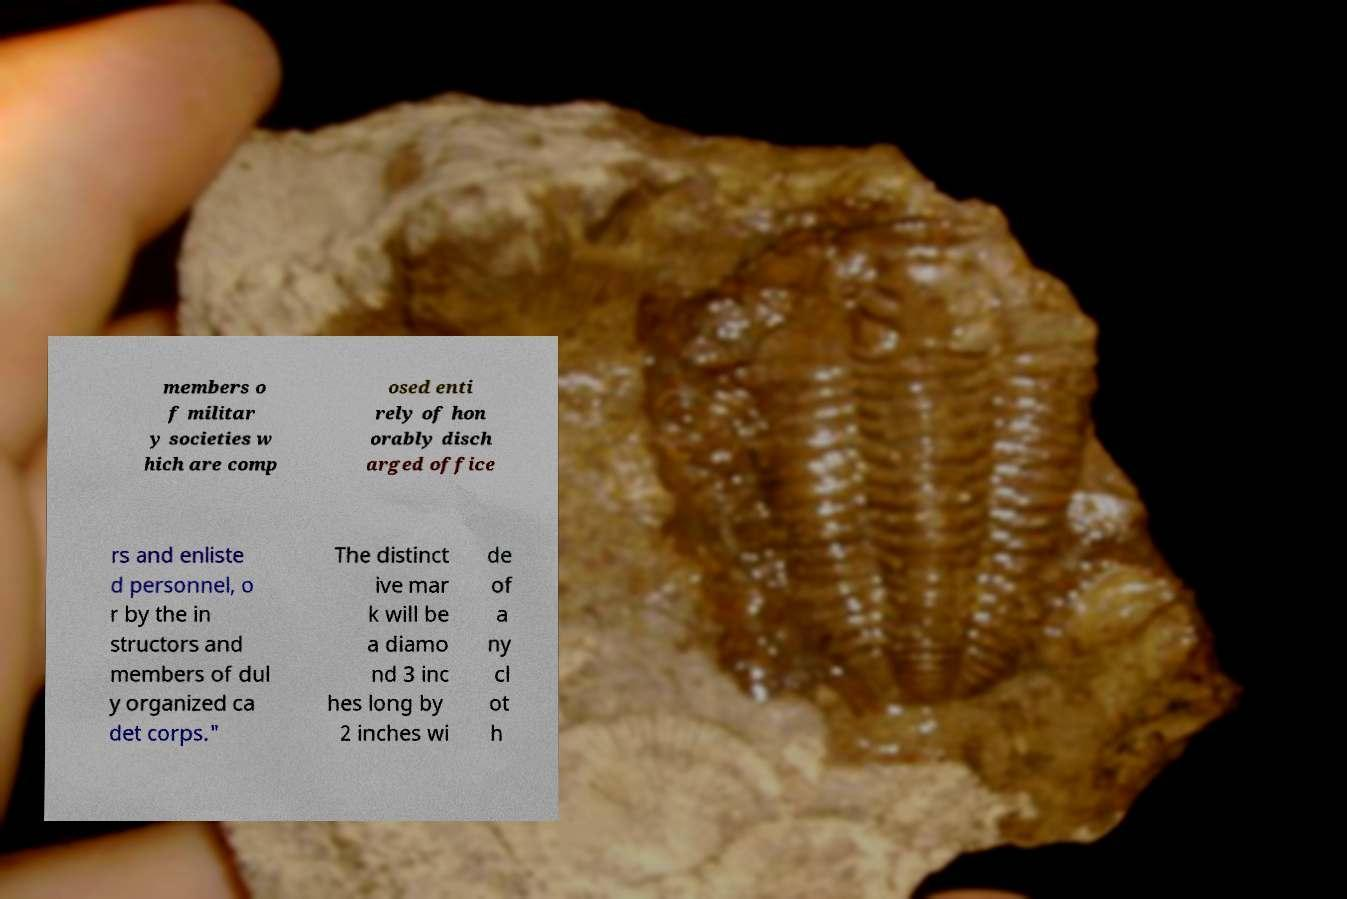Please read and relay the text visible in this image. What does it say? members o f militar y societies w hich are comp osed enti rely of hon orably disch arged office rs and enliste d personnel, o r by the in structors and members of dul y organized ca det corps." The distinct ive mar k will be a diamo nd 3 inc hes long by 2 inches wi de of a ny cl ot h 